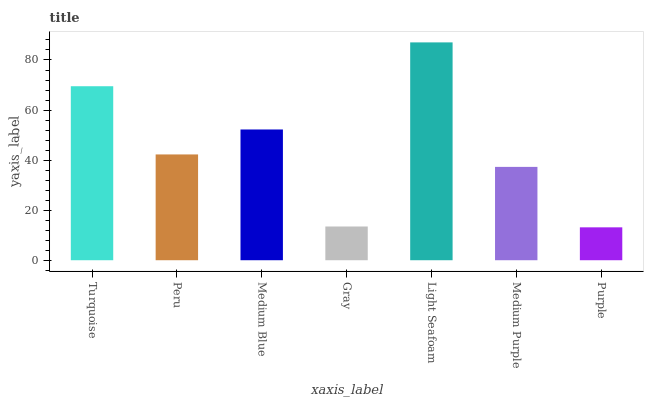Is Purple the minimum?
Answer yes or no. Yes. Is Light Seafoam the maximum?
Answer yes or no. Yes. Is Peru the minimum?
Answer yes or no. No. Is Peru the maximum?
Answer yes or no. No. Is Turquoise greater than Peru?
Answer yes or no. Yes. Is Peru less than Turquoise?
Answer yes or no. Yes. Is Peru greater than Turquoise?
Answer yes or no. No. Is Turquoise less than Peru?
Answer yes or no. No. Is Peru the high median?
Answer yes or no. Yes. Is Peru the low median?
Answer yes or no. Yes. Is Turquoise the high median?
Answer yes or no. No. Is Medium Blue the low median?
Answer yes or no. No. 